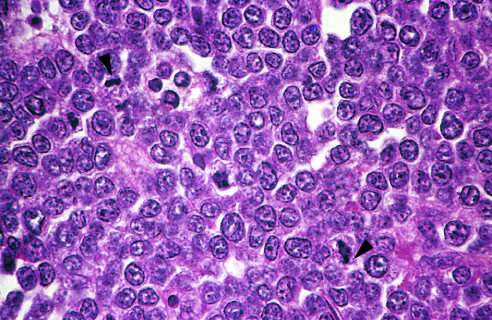what is produced by interspersed, lightly staining, normal microphages?
Answer the question using a single word or phrase. The starry sky pattern 